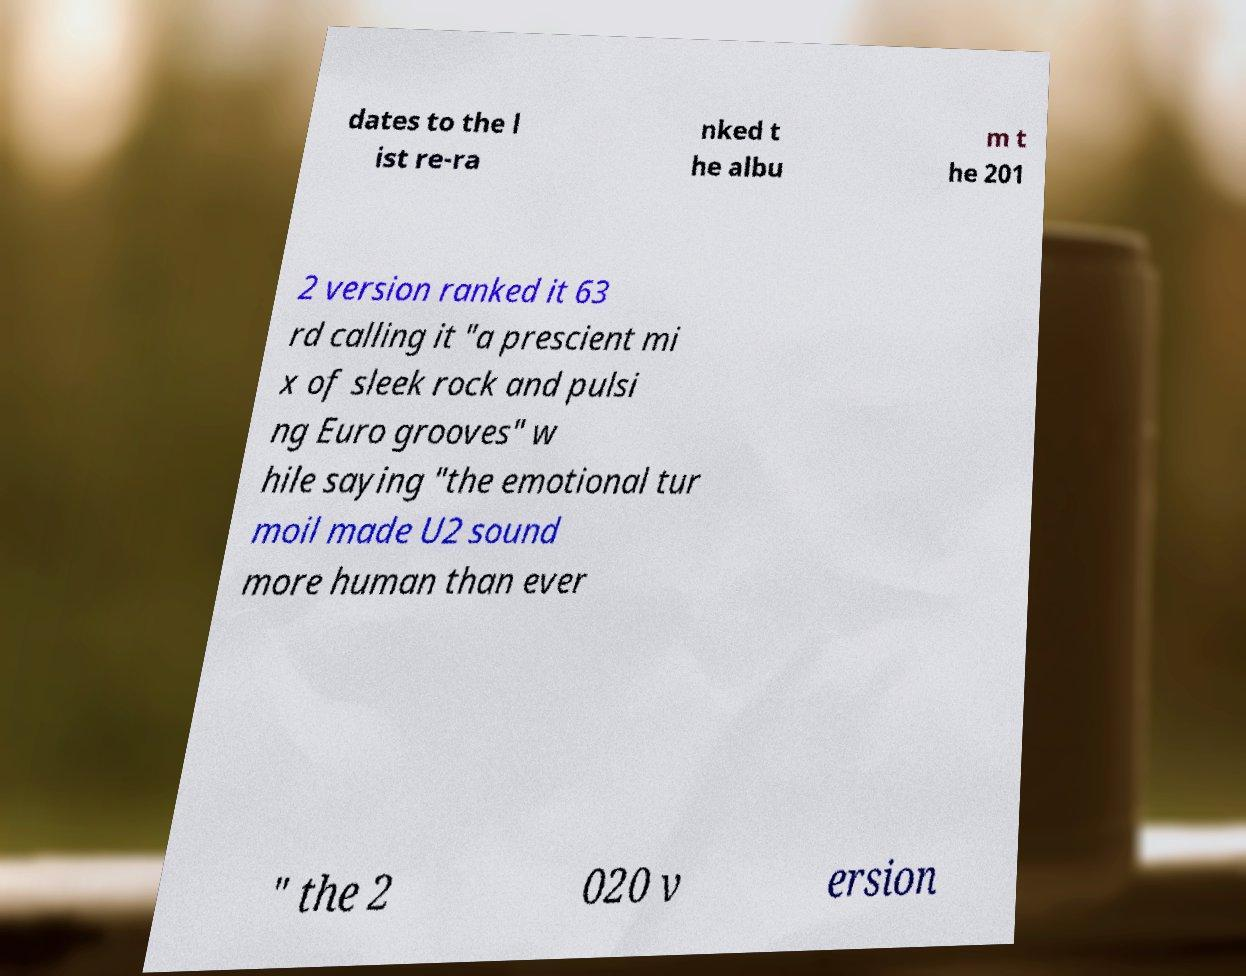For documentation purposes, I need the text within this image transcribed. Could you provide that? dates to the l ist re-ra nked t he albu m t he 201 2 version ranked it 63 rd calling it "a prescient mi x of sleek rock and pulsi ng Euro grooves" w hile saying "the emotional tur moil made U2 sound more human than ever " the 2 020 v ersion 